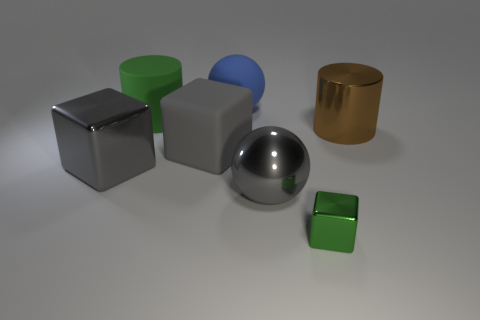Subtract all large cubes. How many cubes are left? 1 Add 1 matte balls. How many objects exist? 8 Subtract all cylinders. How many objects are left? 5 Add 5 large spheres. How many large spheres exist? 7 Subtract 1 gray spheres. How many objects are left? 6 Subtract all big gray balls. Subtract all large metallic balls. How many objects are left? 5 Add 7 cylinders. How many cylinders are left? 9 